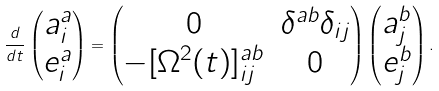Convert formula to latex. <formula><loc_0><loc_0><loc_500><loc_500>\frac { d } { d t } \begin{pmatrix} a ^ { a } _ { i } \\ e ^ { a } _ { i } \end{pmatrix} = \begin{pmatrix} 0 & \delta ^ { a b } \delta _ { i j } \\ - [ \Omega ^ { 2 } ( t ) ] ^ { a b } _ { i j } & 0 \end{pmatrix} \begin{pmatrix} a ^ { b } _ { j } \\ e ^ { b } _ { j } \end{pmatrix} .</formula> 